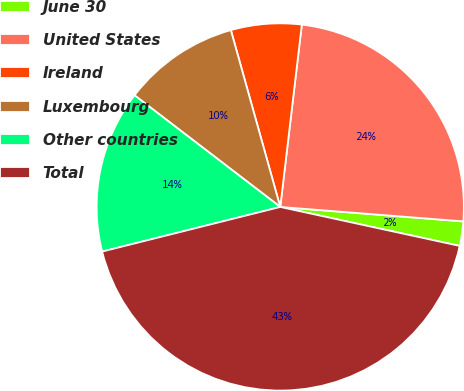<chart> <loc_0><loc_0><loc_500><loc_500><pie_chart><fcel>June 30<fcel>United States<fcel>Ireland<fcel>Luxembourg<fcel>Other countries<fcel>Total<nl><fcel>2.15%<fcel>24.38%<fcel>6.21%<fcel>10.26%<fcel>14.31%<fcel>42.69%<nl></chart> 